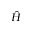Convert formula to latex. <formula><loc_0><loc_0><loc_500><loc_500>\hat { H }</formula> 